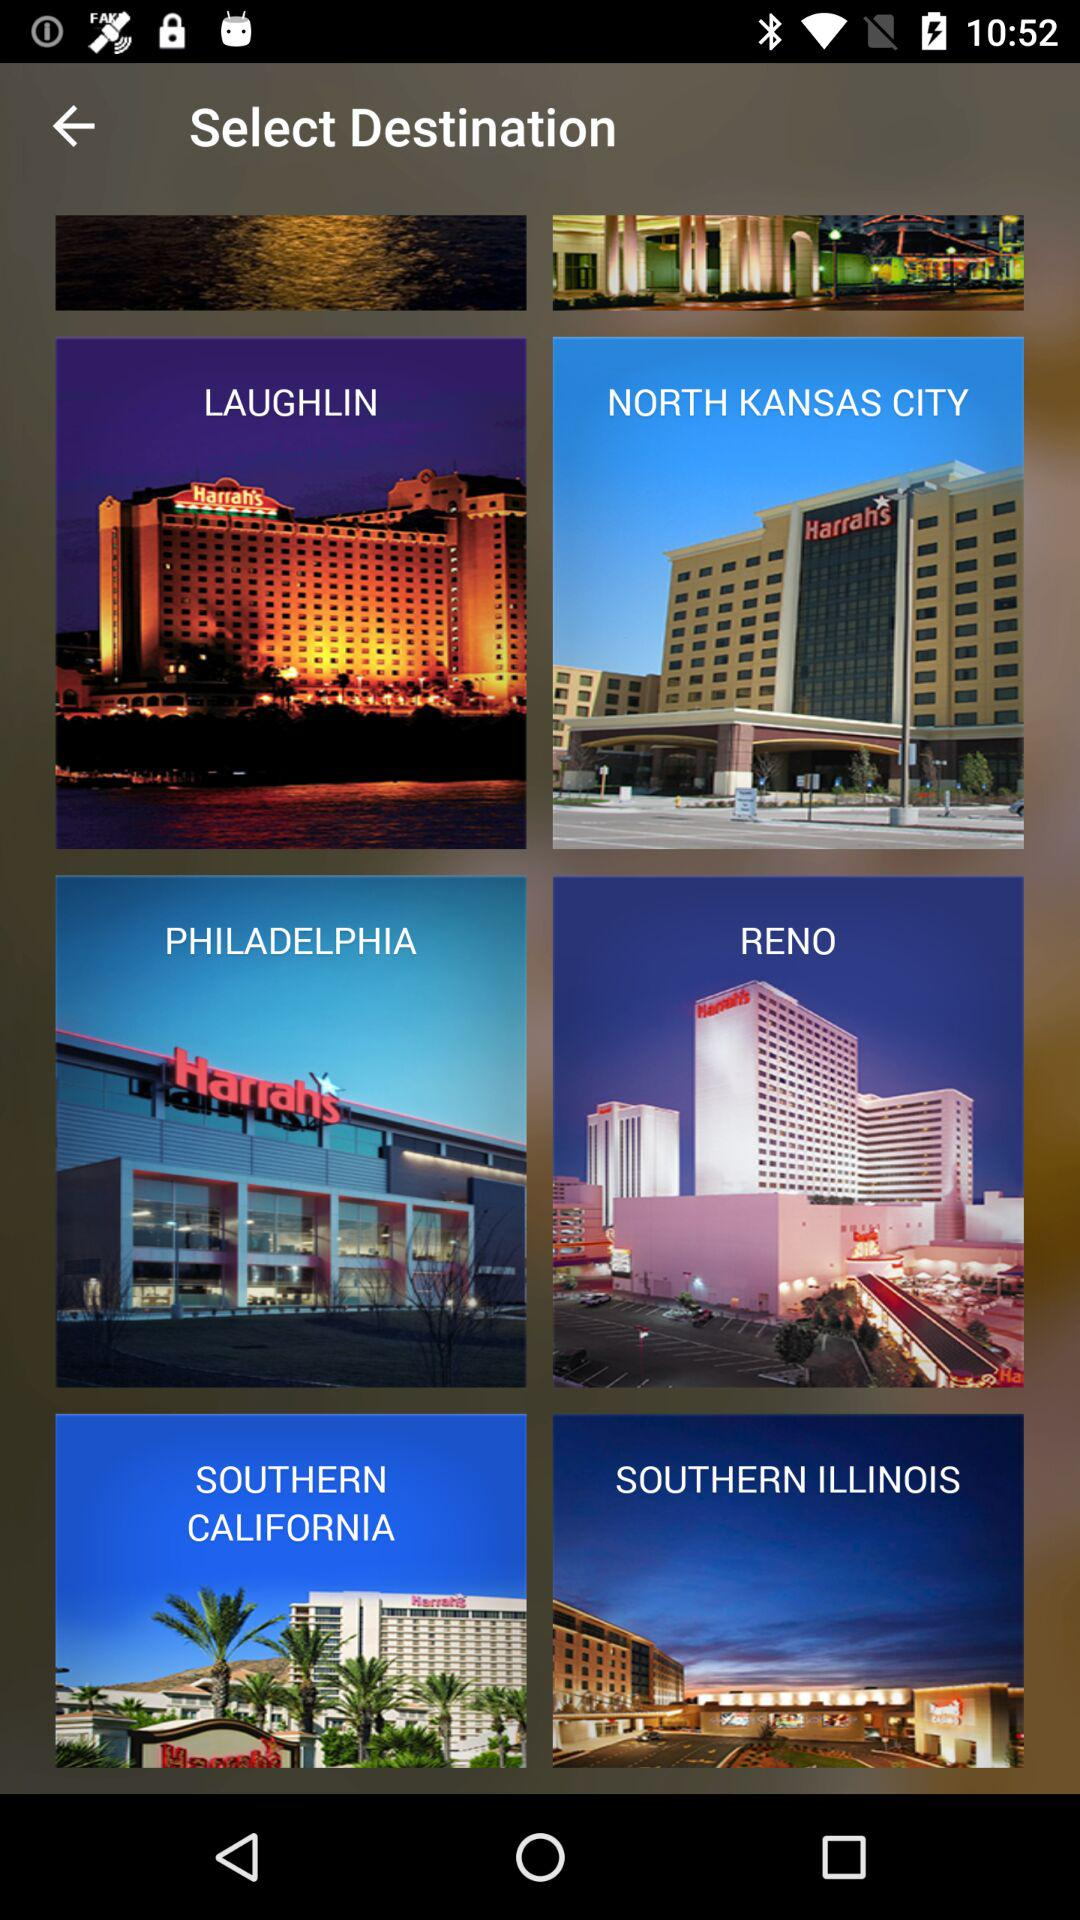Which are the different destinations? The different destinations are Laughlin, North Kansas City, Philadelphia, Reno, Southern California and Southern Illinois. 